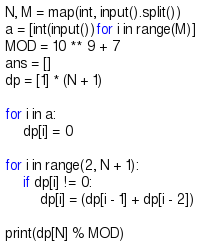Convert code to text. <code><loc_0><loc_0><loc_500><loc_500><_Python_>N, M = map(int, input().split())
a = [int(input())for i in range(M)]
MOD = 10 ** 9 + 7
ans = []
dp = [1] * (N + 1)

for i in a:
    dp[i] = 0

for i in range(2, N + 1):
    if dp[i] != 0:
        dp[i] = (dp[i - 1] + dp[i - 2])

print(dp[N] % MOD)
</code> 